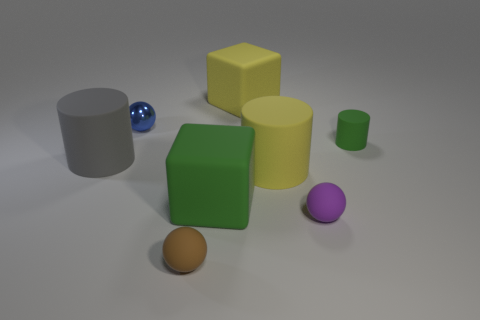Is there any other thing that has the same material as the blue ball?
Your answer should be very brief. No. Is the color of the small metallic sphere the same as the tiny rubber cylinder?
Ensure brevity in your answer.  No. What number of blocks are rubber objects or blue metallic things?
Your answer should be compact. 2. What is the material of the tiny sphere that is both behind the tiny brown matte object and to the left of the big green thing?
Offer a very short reply. Metal. There is a big green thing; how many big green cubes are in front of it?
Provide a short and direct response. 0. Are the green thing behind the big yellow cylinder and the big yellow object that is behind the tiny cylinder made of the same material?
Your answer should be very brief. Yes. What number of objects are big rubber objects that are to the left of the tiny metal object or big cubes?
Provide a succinct answer. 3. Is the number of purple balls that are behind the small green matte cylinder less than the number of small brown matte spheres that are left of the small blue shiny sphere?
Make the answer very short. No. What number of other things are there of the same size as the gray cylinder?
Ensure brevity in your answer.  3. Is the material of the gray cylinder the same as the tiny sphere that is behind the purple matte object?
Offer a terse response. No. 